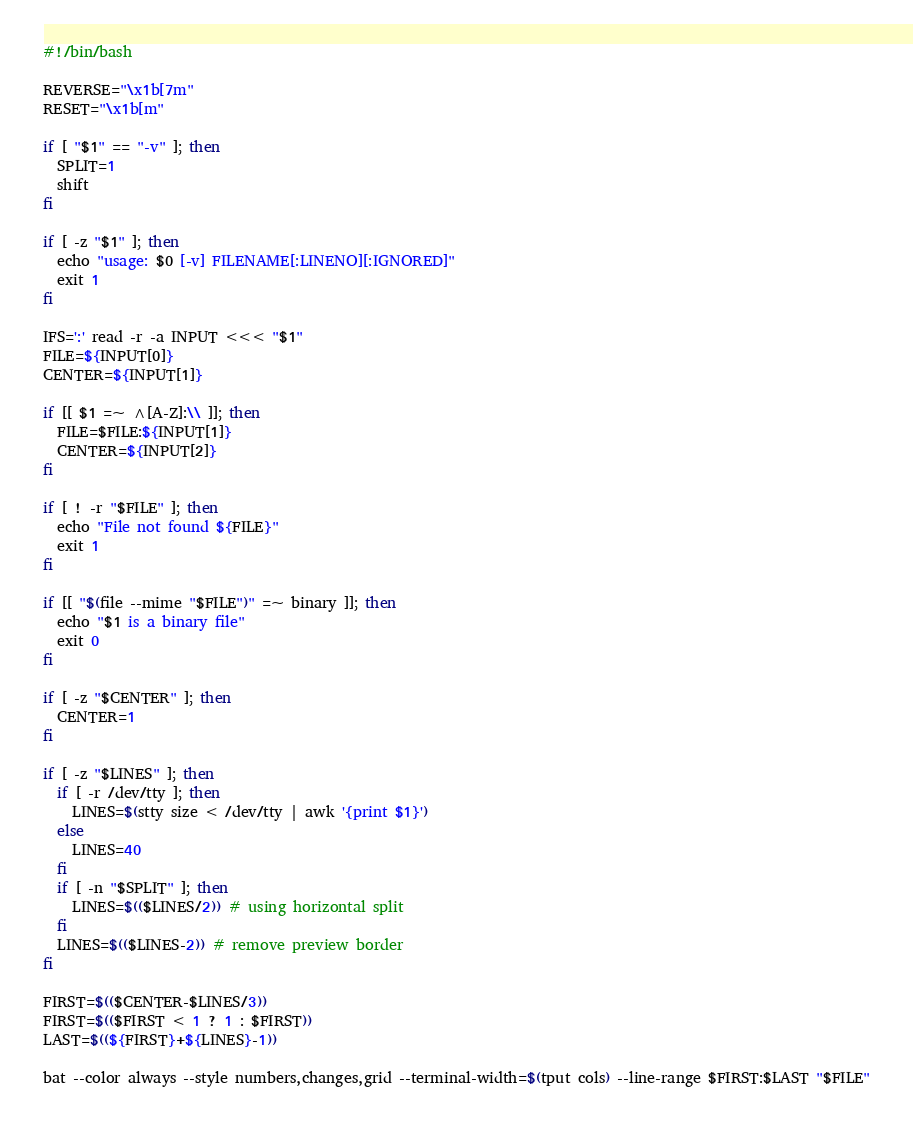Convert code to text. <code><loc_0><loc_0><loc_500><loc_500><_Bash_>#!/bin/bash

REVERSE="\x1b[7m"
RESET="\x1b[m"

if [ "$1" == "-v" ]; then
  SPLIT=1
  shift
fi

if [ -z "$1" ]; then
  echo "usage: $0 [-v] FILENAME[:LINENO][:IGNORED]"
  exit 1
fi

IFS=':' read -r -a INPUT <<< "$1"
FILE=${INPUT[0]}
CENTER=${INPUT[1]}

if [[ $1 =~ ^[A-Z]:\\ ]]; then
  FILE=$FILE:${INPUT[1]}
  CENTER=${INPUT[2]}
fi

if [ ! -r "$FILE" ]; then
  echo "File not found ${FILE}"
  exit 1
fi

if [[ "$(file --mime "$FILE")" =~ binary ]]; then
  echo "$1 is a binary file"
  exit 0
fi

if [ -z "$CENTER" ]; then
  CENTER=1
fi

if [ -z "$LINES" ]; then
  if [ -r /dev/tty ]; then
    LINES=$(stty size < /dev/tty | awk '{print $1}')
  else
    LINES=40
  fi
  if [ -n "$SPLIT" ]; then
    LINES=$(($LINES/2)) # using horizontal split
  fi
  LINES=$(($LINES-2)) # remove preview border
fi

FIRST=$(($CENTER-$LINES/3))
FIRST=$(($FIRST < 1 ? 1 : $FIRST))
LAST=$((${FIRST}+${LINES}-1))

bat --color always --style numbers,changes,grid --terminal-width=$(tput cols) --line-range $FIRST:$LAST "$FILE"
</code> 